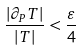Convert formula to latex. <formula><loc_0><loc_0><loc_500><loc_500>\frac { | \partial _ { P } T | } { | T | } < \frac { \varepsilon } 4</formula> 